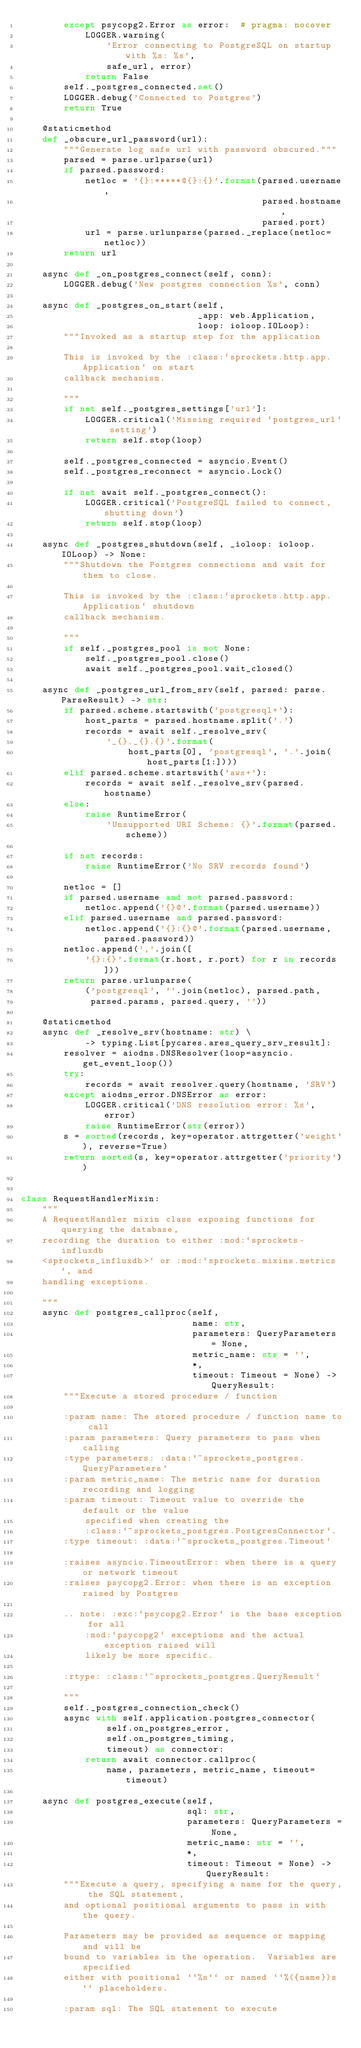Convert code to text. <code><loc_0><loc_0><loc_500><loc_500><_Python_>        except psycopg2.Error as error:  # pragma: nocover
            LOGGER.warning(
                'Error connecting to PostgreSQL on startup with %s: %s',
                safe_url, error)
            return False
        self._postgres_connected.set()
        LOGGER.debug('Connected to Postgres')
        return True

    @staticmethod
    def _obscure_url_password(url):
        """Generate log safe url with password obscured."""
        parsed = parse.urlparse(url)
        if parsed.password:
            netloc = '{}:*****@{}:{}'.format(parsed.username,
                                             parsed.hostname,
                                             parsed.port)
            url = parse.urlunparse(parsed._replace(netloc=netloc))
        return url

    async def _on_postgres_connect(self, conn):
        LOGGER.debug('New postgres connection %s', conn)

    async def _postgres_on_start(self,
                                 _app: web.Application,
                                 loop: ioloop.IOLoop):
        """Invoked as a startup step for the application

        This is invoked by the :class:`sprockets.http.app.Application` on start
        callback mechanism.

        """
        if not self._postgres_settings['url']:
            LOGGER.critical('Missing required `postgres_url` setting')
            return self.stop(loop)

        self._postgres_connected = asyncio.Event()
        self._postgres_reconnect = asyncio.Lock()

        if not await self._postgres_connect():
            LOGGER.critical('PostgreSQL failed to connect, shutting down')
            return self.stop(loop)

    async def _postgres_shutdown(self, _ioloop: ioloop.IOLoop) -> None:
        """Shutdown the Postgres connections and wait for them to close.

        This is invoked by the :class:`sprockets.http.app.Application` shutdown
        callback mechanism.

        """
        if self._postgres_pool is not None:
            self._postgres_pool.close()
            await self._postgres_pool.wait_closed()

    async def _postgres_url_from_srv(self, parsed: parse.ParseResult) -> str:
        if parsed.scheme.startswith('postgresql+'):
            host_parts = parsed.hostname.split('.')
            records = await self._resolve_srv(
                '_{}._{}.{}'.format(
                    host_parts[0], 'postgresql', '.'.join(host_parts[1:])))
        elif parsed.scheme.startswith('aws+'):
            records = await self._resolve_srv(parsed.hostname)
        else:
            raise RuntimeError(
                'Unsupported URI Scheme: {}'.format(parsed.scheme))

        if not records:
            raise RuntimeError('No SRV records found')

        netloc = []
        if parsed.username and not parsed.password:
            netloc.append('{}@'.format(parsed.username))
        elif parsed.username and parsed.password:
            netloc.append('{}:{}@'.format(parsed.username, parsed.password))
        netloc.append(','.join([
            '{}:{}'.format(r.host, r.port) for r in records]))
        return parse.urlunparse(
            ('postgresql', ''.join(netloc), parsed.path,
             parsed.params, parsed.query, ''))

    @staticmethod
    async def _resolve_srv(hostname: str) \
            -> typing.List[pycares.ares_query_srv_result]:
        resolver = aiodns.DNSResolver(loop=asyncio.get_event_loop())
        try:
            records = await resolver.query(hostname, 'SRV')
        except aiodns_error.DNSError as error:
            LOGGER.critical('DNS resolution error: %s', error)
            raise RuntimeError(str(error))
        s = sorted(records, key=operator.attrgetter('weight'), reverse=True)
        return sorted(s, key=operator.attrgetter('priority'))


class RequestHandlerMixin:
    """
    A RequestHandler mixin class exposing functions for querying the database,
    recording the duration to either :mod:`sprockets-influxdb
    <sprockets_influxdb>` or :mod:`sprockets.mixins.metrics`, and
    handling exceptions.

    """
    async def postgres_callproc(self,
                                name: str,
                                parameters: QueryParameters = None,
                                metric_name: str = '',
                                *,
                                timeout: Timeout = None) -> QueryResult:
        """Execute a stored procedure / function

        :param name: The stored procedure / function name to call
        :param parameters: Query parameters to pass when calling
        :type parameters: :data:`~sprockets_postgres.QueryParameters`
        :param metric_name: The metric name for duration recording and logging
        :param timeout: Timeout value to override the default or the value
            specified when creating the
            :class:`~sprockets_postgres.PostgresConnector`.
        :type timeout: :data:`~sprockets_postgres.Timeout`

        :raises asyncio.TimeoutError: when there is a query or network timeout
        :raises psycopg2.Error: when there is an exception raised by Postgres

        .. note: :exc:`psycopg2.Error` is the base exception for all
            :mod:`psycopg2` exceptions and the actual exception raised will
            likely be more specific.

        :rtype: :class:`~sprockets_postgres.QueryResult`

        """
        self._postgres_connection_check()
        async with self.application.postgres_connector(
                self.on_postgres_error,
                self.on_postgres_timing,
                timeout) as connector:
            return await connector.callproc(
                name, parameters, metric_name, timeout=timeout)

    async def postgres_execute(self,
                               sql: str,
                               parameters: QueryParameters = None,
                               metric_name: str = '',
                               *,
                               timeout: Timeout = None) -> QueryResult:
        """Execute a query, specifying a name for the query, the SQL statement,
        and optional positional arguments to pass in with the query.

        Parameters may be provided as sequence or mapping and will be
        bound to variables in the operation.  Variables are specified
        either with positional ``%s`` or named ``%({name})s`` placeholders.

        :param sql: The SQL statement to execute</code> 